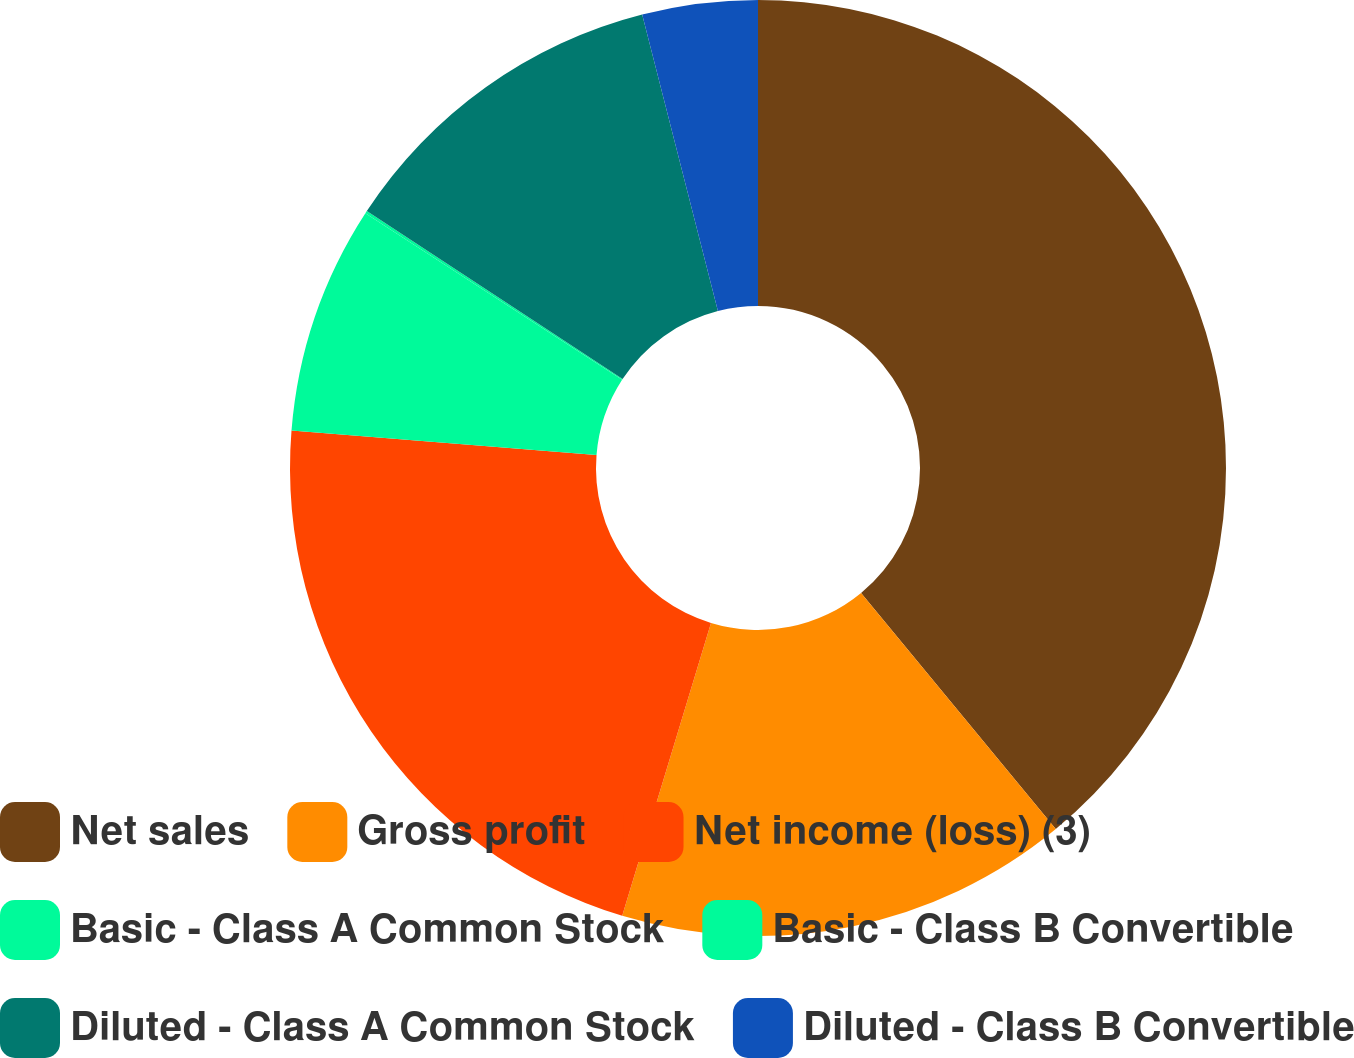Convert chart to OTSL. <chart><loc_0><loc_0><loc_500><loc_500><pie_chart><fcel>Net sales<fcel>Gross profit<fcel>Net income (loss) (3)<fcel>Basic - Class A Common Stock<fcel>Basic - Class B Convertible<fcel>Diluted - Class A Common Stock<fcel>Diluted - Class B Convertible<nl><fcel>39.02%<fcel>15.66%<fcel>21.59%<fcel>7.88%<fcel>0.09%<fcel>11.77%<fcel>3.98%<nl></chart> 